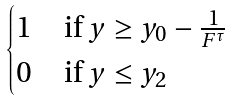<formula> <loc_0><loc_0><loc_500><loc_500>\begin{cases} 1 \quad \text {if } y \geq y _ { 0 } - \frac { 1 } { F ^ { \tau } } \\ 0 \quad \text {if } y \leq y _ { 2 } \end{cases}</formula> 